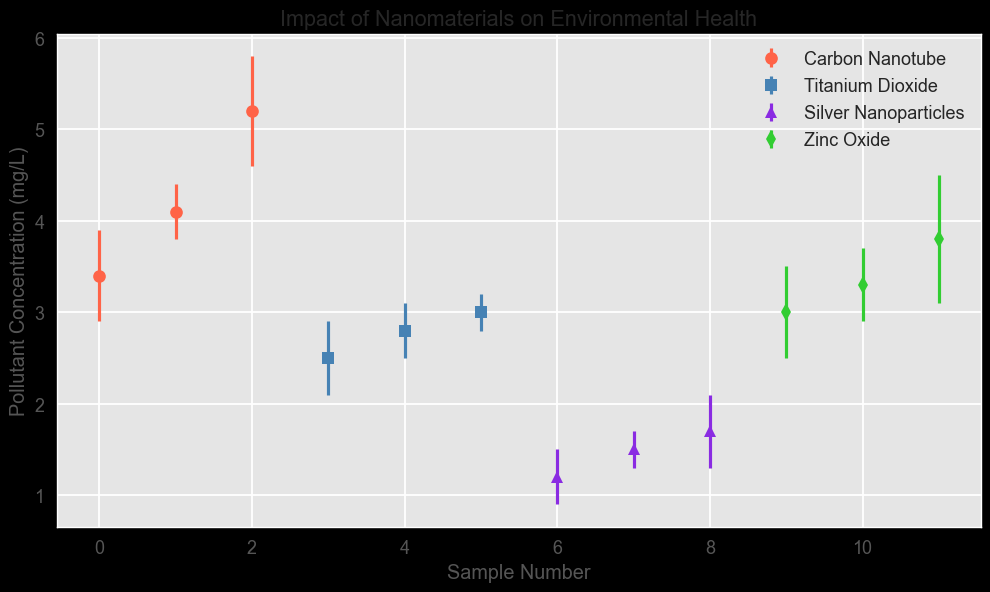What nanomaterial type shows the highest average pollutant concentration? To find the highest average pollutant concentration, we need to compute the mean concentration for each nanomaterial type. For 'Carbon Nanotube': (3.4 + 4.1 + 5.2)/3 = 4.23 mg/L. For 'Titanium Dioxide': (2.5 + 2.8 + 3.0)/3 = 2.77 mg/L. For 'Silver Nanoparticles': (1.2 + 1.5 + 1.7)/3 = 1.47 mg/L. For 'Zinc Oxide': (3.0 + 3.3 + 3.8)/3 = 3.37 mg/L. Comparing these averages, 'Carbon Nanotube' has the highest average concentration.
Answer: Carbon Nanotube Which nanomaterial has the lowest variability in pollutant concentration? To determine the lowest variability, we should look at the standard deviations. 'Carbon Nanotube' has standard deviations of 0.5, 0.3, 0.6, giving an average deviation of (0.5+0.3+0.6)/3 = 0.47. 'Titanium Dioxide' has 0.4, 0.3, 0.2, giving an average deviation of (0.4+0.3+0.2)/3 = 0.3. 'Silver Nanoparticles' has 0.3, 0.2, 0.4, giving an average deviation of (0.3+0.2+0.4)/3= 0.3. 'Zinc Oxide' has 0.5, 0.4, 0.7, giving an average deviation of (0.5+0.4+0.7)/3= 0.53. The lowest average deviation (indicating the lowest variability) is for 'Titanium Dioxide' and 'Silver Nanoparticles' at 0.3.
Answer: Titanium Dioxide and Silver Nanoparticles Do Carbon Nanotubes exhibit higher pollutant concentrations than Titanium Dioxide? To compare pollutant concentrations between Carbon Nanotubes and Titanium Dioxide, we look at their respective data points. Carbon Nanotube concentrations are 3.4, 4.1, 5.2 mg/L, with an average of 4.23 mg/L. Titanium Dioxide concentrations are 2.5, 2.8, 3.0 mg/L, with an average of 2.77 mg/L. Since the average for Carbon Nanotubes (4.23 mg/L) is higher than for Titanium Dioxide (2.77 mg/L), Carbon Nanotubes exhibit higher pollutant concentrations.
Answer: Yes Which sample number has the highest pollutant concentration for Zinc Oxide? Looking at the Zinc Oxide data points, their positions correspond to sample numbers. The concentrations are 3.0, 3.3, and 3.8 mg/L. The highest concentration is 3.8 mg/L, which corresponds to the last sample in that series.
Answer: The last sample For Silver Nanoparticles, what's the range (difference between the highest and lowest values) of pollutant concentrations? For Silver Nanoparticles, the concentrations are 1.2, 1.5, and 1.7 mg/L. The range is calculated by subtracting the lowest value from the highest value, which gives: 1.7 - 1.2 = 0.5 mg/L.
Answer: 0.5 mg/L 